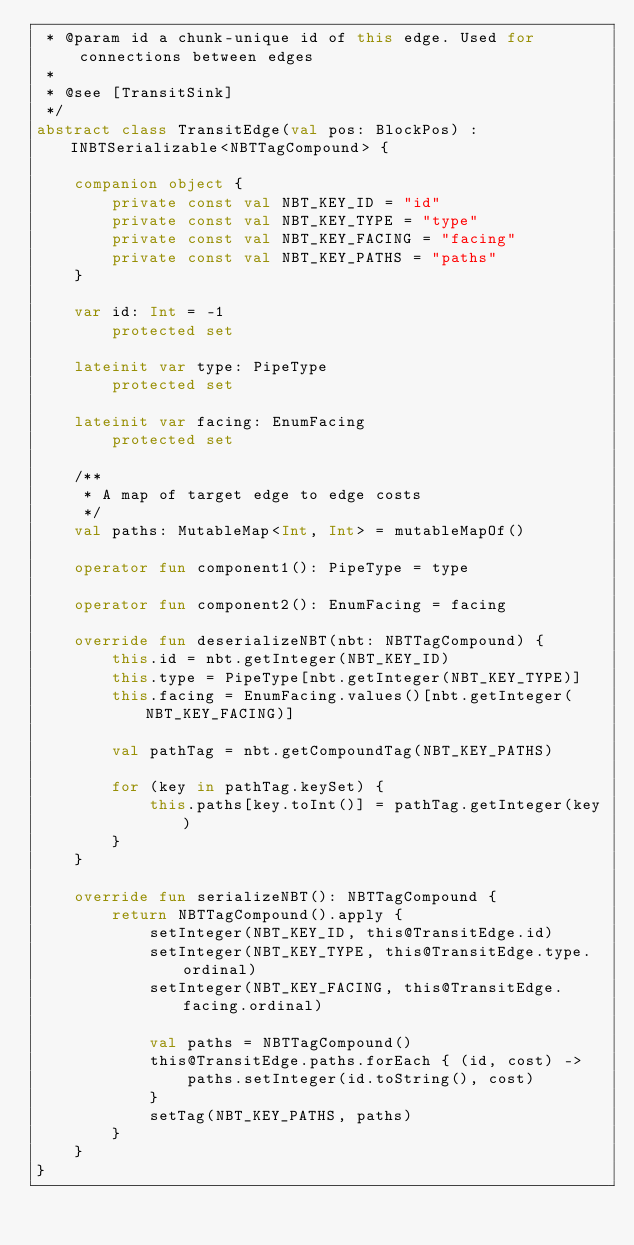Convert code to text. <code><loc_0><loc_0><loc_500><loc_500><_Kotlin_> * @param id a chunk-unique id of this edge. Used for connections between edges
 *
 * @see [TransitSink]
 */
abstract class TransitEdge(val pos: BlockPos) : INBTSerializable<NBTTagCompound> {

    companion object {
        private const val NBT_KEY_ID = "id"
        private const val NBT_KEY_TYPE = "type"
        private const val NBT_KEY_FACING = "facing"
        private const val NBT_KEY_PATHS = "paths"
    }

    var id: Int = -1
        protected set

    lateinit var type: PipeType
        protected set

    lateinit var facing: EnumFacing
        protected set

    /**
     * A map of target edge to edge costs
     */
    val paths: MutableMap<Int, Int> = mutableMapOf()

    operator fun component1(): PipeType = type

    operator fun component2(): EnumFacing = facing

    override fun deserializeNBT(nbt: NBTTagCompound) {
        this.id = nbt.getInteger(NBT_KEY_ID)
        this.type = PipeType[nbt.getInteger(NBT_KEY_TYPE)]
        this.facing = EnumFacing.values()[nbt.getInteger(NBT_KEY_FACING)]

        val pathTag = nbt.getCompoundTag(NBT_KEY_PATHS)

        for (key in pathTag.keySet) {
            this.paths[key.toInt()] = pathTag.getInteger(key)
        }
    }

    override fun serializeNBT(): NBTTagCompound {
        return NBTTagCompound().apply {
            setInteger(NBT_KEY_ID, this@TransitEdge.id)
            setInteger(NBT_KEY_TYPE, this@TransitEdge.type.ordinal)
            setInteger(NBT_KEY_FACING, this@TransitEdge.facing.ordinal)

            val paths = NBTTagCompound()
            this@TransitEdge.paths.forEach { (id, cost) ->
                paths.setInteger(id.toString(), cost)
            }
            setTag(NBT_KEY_PATHS, paths)
        }
    }
}</code> 